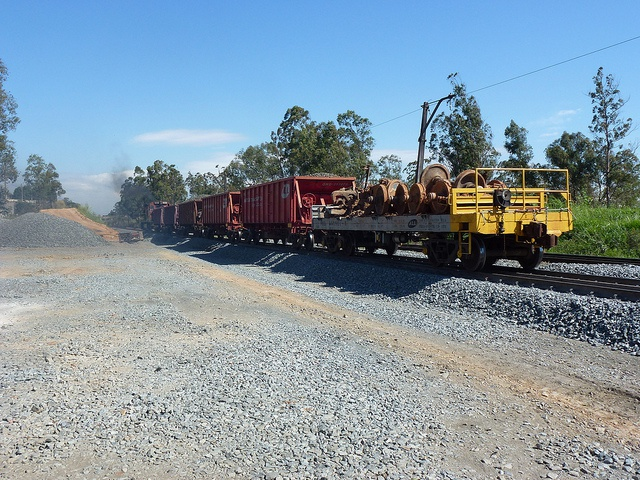Describe the objects in this image and their specific colors. I can see a train in lightblue, black, gray, maroon, and olive tones in this image. 